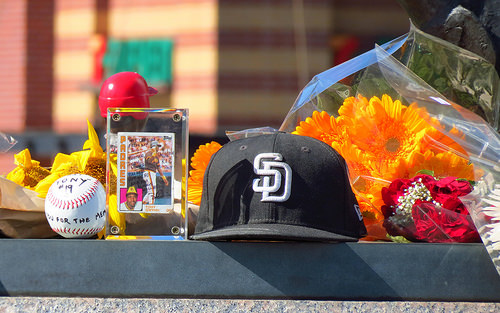<image>
Is there a cap to the left of the ball? No. The cap is not to the left of the ball. From this viewpoint, they have a different horizontal relationship. 